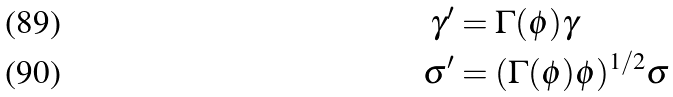Convert formula to latex. <formula><loc_0><loc_0><loc_500><loc_500>\gamma ^ { \prime } & = \Gamma ( \phi ) \gamma \\ \sigma ^ { \prime } & = ( \Gamma ( \phi ) \phi ) ^ { 1 / 2 } \sigma</formula> 